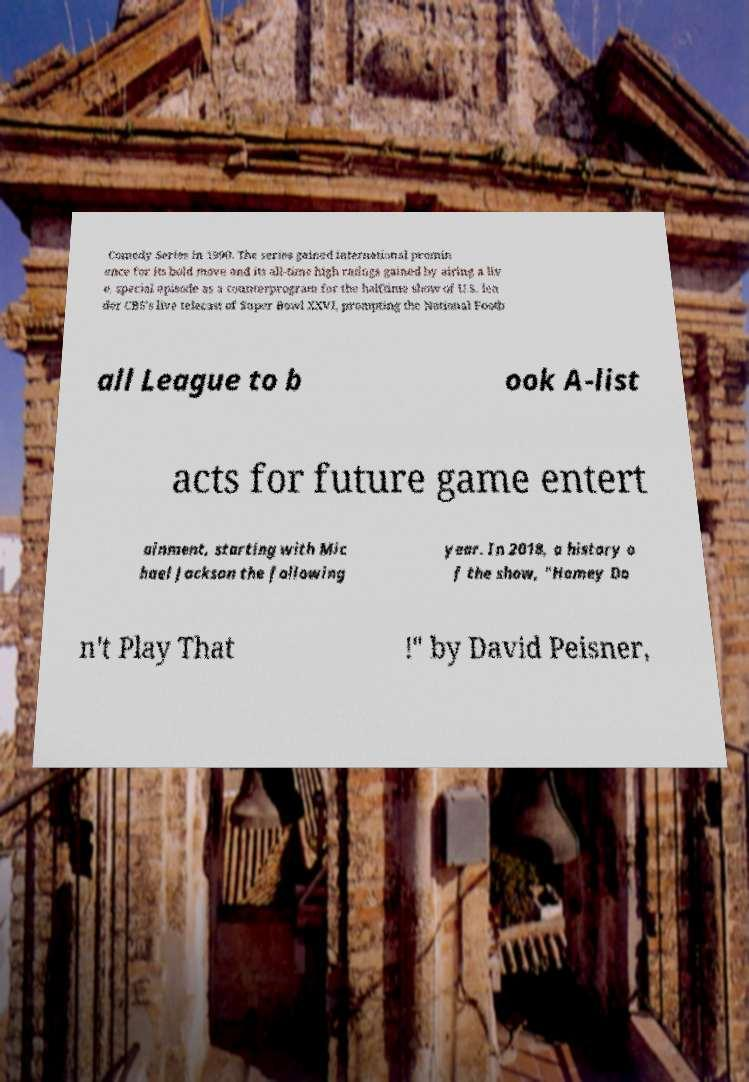Could you extract and type out the text from this image? Comedy Series in 1990. The series gained international promin ence for its bold move and its all-time high ratings gained by airing a liv e, special episode as a counterprogram for the halftime show of U.S. lea der CBS's live telecast of Super Bowl XXVI, prompting the National Footb all League to b ook A-list acts for future game entert ainment, starting with Mic hael Jackson the following year. In 2018, a history o f the show, "Homey Do n't Play That !" by David Peisner, 